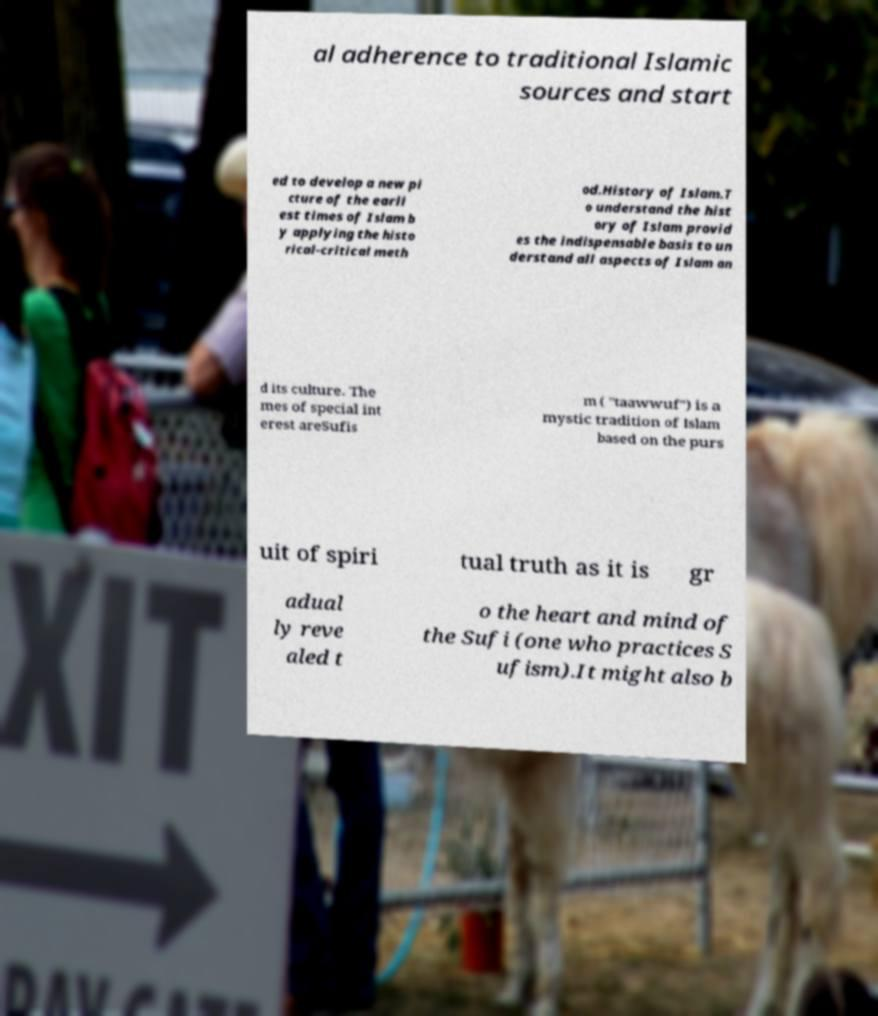Please read and relay the text visible in this image. What does it say? al adherence to traditional Islamic sources and start ed to develop a new pi cture of the earli est times of Islam b y applying the histo rical-critical meth od.History of Islam.T o understand the hist ory of Islam provid es the indispensable basis to un derstand all aspects of Islam an d its culture. The mes of special int erest areSufis m ( "taawwuf") is a mystic tradition of Islam based on the purs uit of spiri tual truth as it is gr adual ly reve aled t o the heart and mind of the Sufi (one who practices S ufism).It might also b 